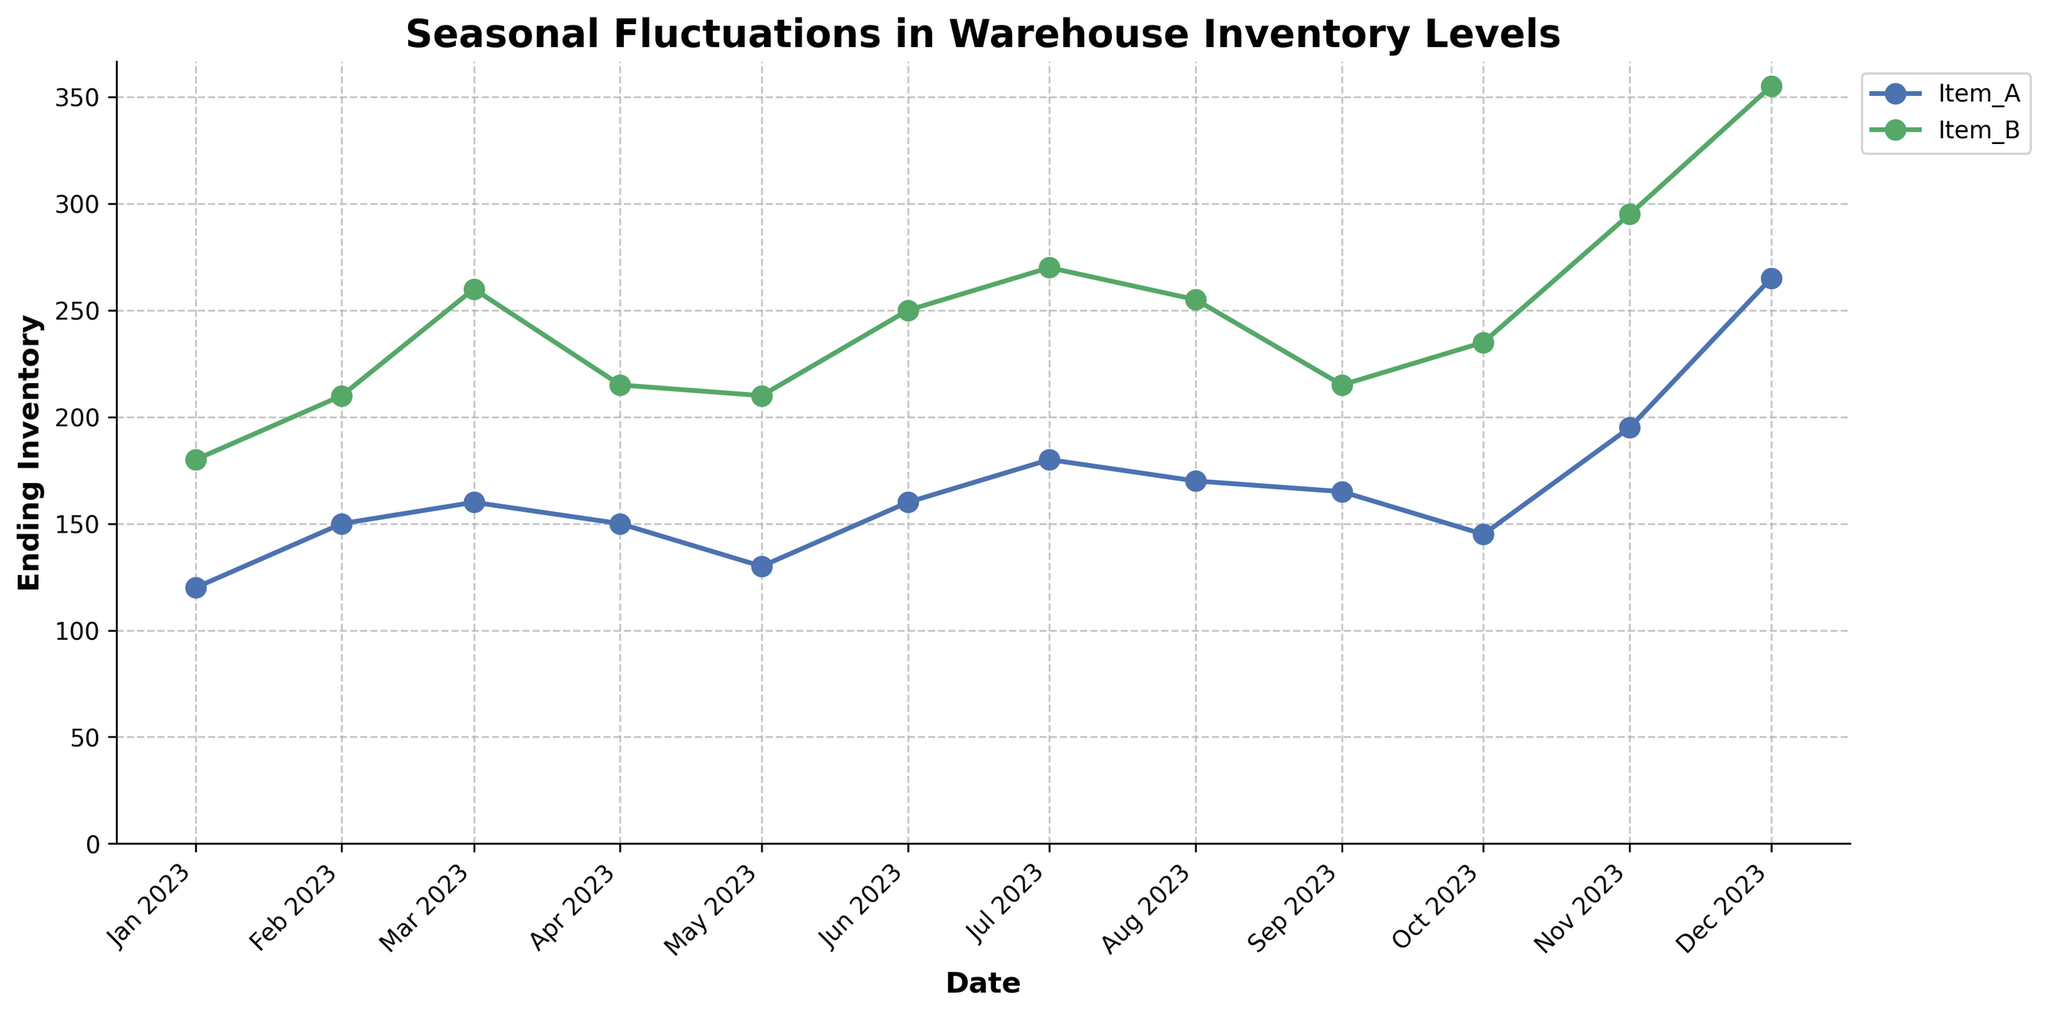What is the title of the plot? The title of the plot is usually located at the top. It summarizes the entire content of the graph.
Answer: Seasonal Fluctuations in Warehouse Inventory Levels Which item has the highest ending inventory in December 2023? Look at the ending points for December 2023 on the x-axis and check which item's line reaches the highest value on the y-axis.
Answer: Item_B How does the ending inventory for Item_A compare between January and December 2023? Trace the line for Item_A from January to December. Note the values at the start and end of the year. Compare these two values by observing the vertical position of the points.
Answer: In January, it was 120; in December, it was 265 What is the overall trend for Item_A's ending inventory over the year? Follow the line representing Item_A through the months from January to December. Observe the general direction whether it is increasing, decreasing, or fluctuating.
Answer: Increasing Which month shows the largest difference in ending inventory between Item_A and Item_B? For each month, calculate the difference between Item_A's and Item_B's ending inventory. Identify the month with the greatest difference by observing the endpoints of their respective lines.
Answer: December 2023 Is there any month where the ending inventory for both items is nearly the same? Scan through each month on the x-axis and check if the endpoints of the lines for Item_A and Item_B are close together.
Answer: October 2023 Across all months, which item generally has a higher ending inventory? Compare the overall height position of the lines for Item_A and Item_B across the entire year. Identify the item that consistently has higher values.
Answer: Item_B Between July and August, how does the ending inventory for Item_A change? Observe the line representing Item_A between July and August. Note the vertical position (y-axis value) for each month. Calculate or describe the change.
Answer: Decreases from 180 to 170 What can you infer about the inventory levels in the last quarter of 2023? Focus on October, November, and December. Observe the trends of the lines for both items in these months. Describe any notable changes or patterns.
Answer: Both items show an increasing trend Which item had a more stable inventory level throughout the year? Assess the variability of the lines representing Item_A and Item_B. The line with less fluctuation (smaller changes between months) indicates greater stability.
Answer: Item_B 